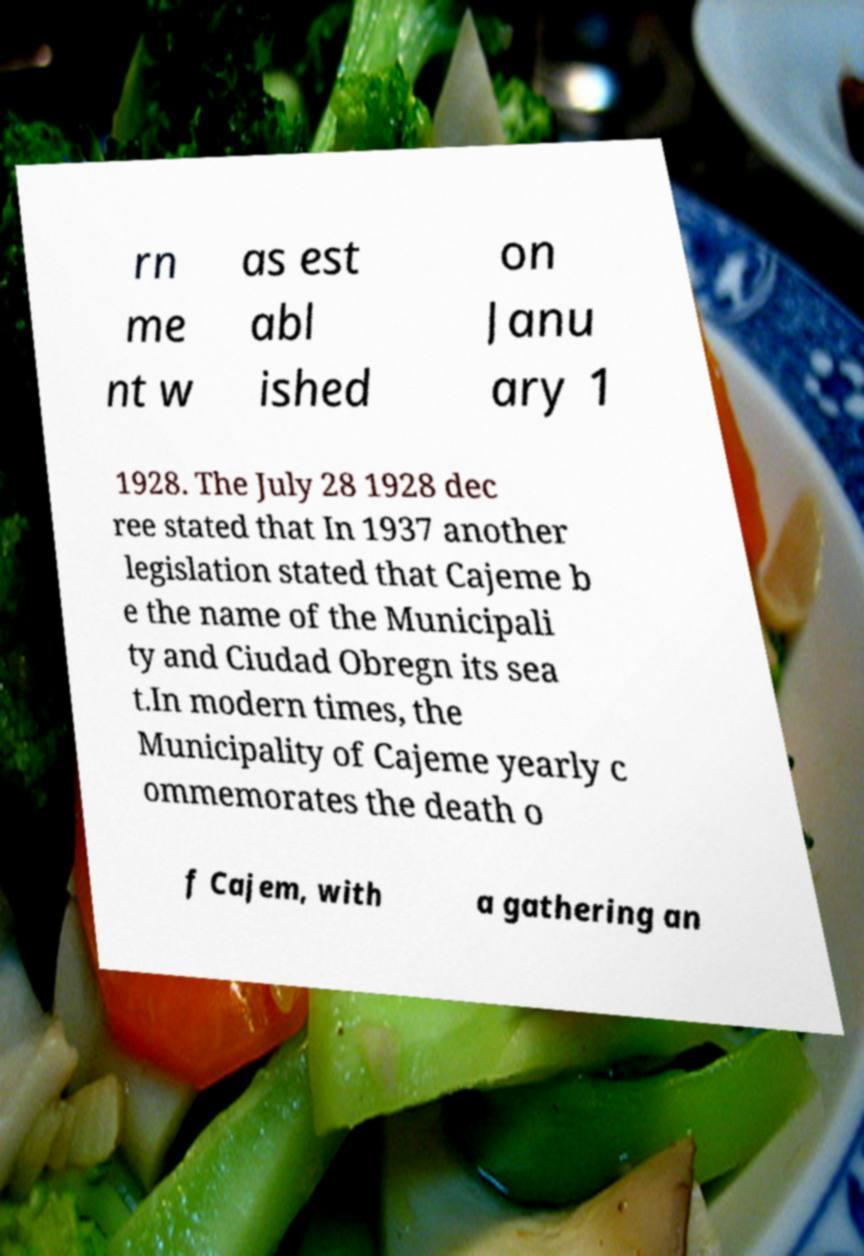Could you extract and type out the text from this image? rn me nt w as est abl ished on Janu ary 1 1928. The July 28 1928 dec ree stated that In 1937 another legislation stated that Cajeme b e the name of the Municipali ty and Ciudad Obregn its sea t.In modern times, the Municipality of Cajeme yearly c ommemorates the death o f Cajem, with a gathering an 